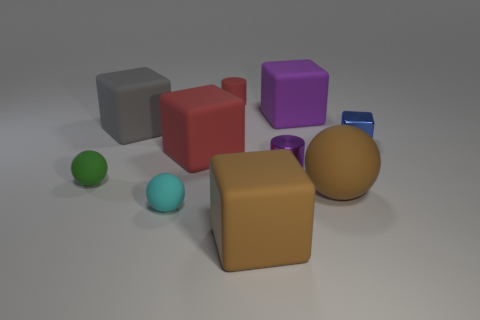What number of cylinders are tiny purple objects or cyan matte objects?
Ensure brevity in your answer.  1. There is a big thing that is both on the right side of the gray rubber cube and on the left side of the big brown rubber block; what shape is it?
Make the answer very short. Cube. What color is the sphere that is behind the ball that is right of the tiny cylinder behind the shiny block?
Provide a short and direct response. Green. Are there fewer large brown rubber spheres that are behind the small green object than big purple things?
Make the answer very short. Yes. There is a brown object to the right of the tiny purple object; does it have the same shape as the blue shiny thing that is right of the large brown block?
Make the answer very short. No. How many objects are large rubber blocks that are in front of the green sphere or red matte objects?
Make the answer very short. 3. There is a cube that is the same color as the small shiny cylinder; what is it made of?
Give a very brief answer. Rubber. There is a rubber thing that is on the right side of the big cube that is to the right of the purple cylinder; is there a brown ball that is behind it?
Ensure brevity in your answer.  No. Is the number of green things that are right of the tiny cyan sphere less than the number of small green rubber spheres that are to the right of the small red thing?
Your answer should be very brief. No. There is a cylinder that is made of the same material as the purple cube; what color is it?
Give a very brief answer. Red. 